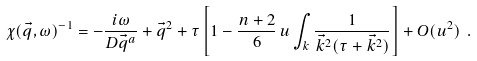<formula> <loc_0><loc_0><loc_500><loc_500>\chi ( \vec { q } , \omega ) ^ { - 1 } = - \frac { i \omega } { D \vec { q } ^ { a } } + \vec { q } ^ { 2 } + \tau \left [ 1 - \frac { n + 2 } { 6 } \, u \int _ { k } \frac { 1 } { \vec { k } ^ { 2 } ( \tau + \vec { k } ^ { 2 } ) } \right ] + O ( u ^ { 2 } ) \ .</formula> 